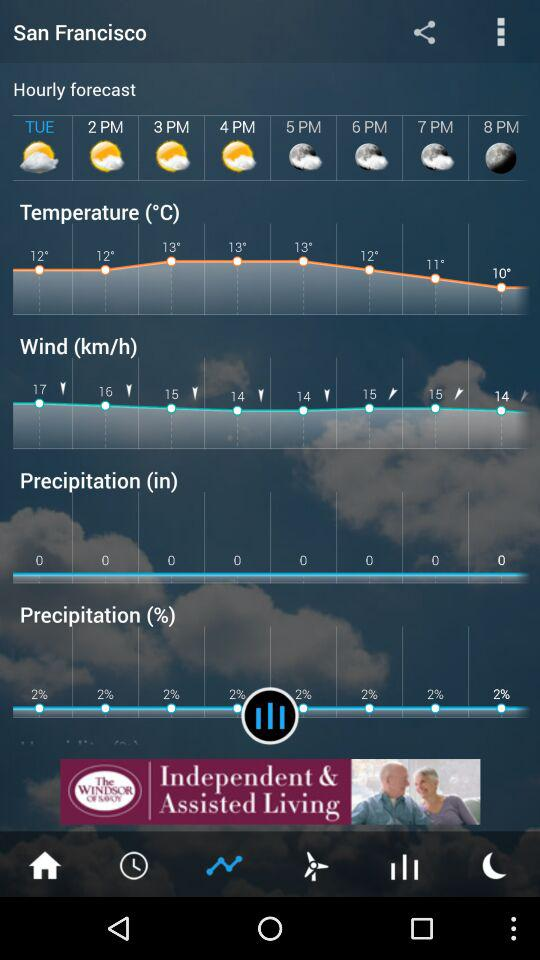What is the minimum temperature?
When the provided information is insufficient, respond with <no answer>. <no answer> 